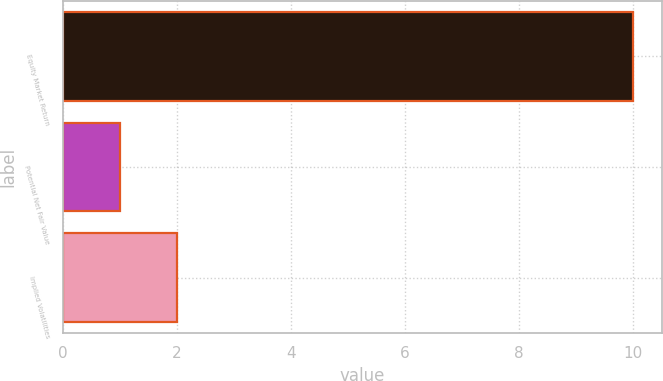Convert chart to OTSL. <chart><loc_0><loc_0><loc_500><loc_500><bar_chart><fcel>Equity Market Return<fcel>Potential Net Fair Value<fcel>Implied Volatilities<nl><fcel>10<fcel>1<fcel>2<nl></chart> 